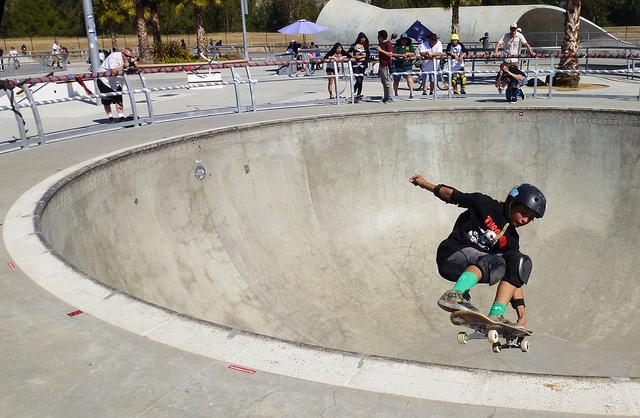What is on the skater's head?
Quick response, please. Helmet. Are there a lot of people?
Concise answer only. No. How many people are skating?
Concise answer only. 1. 